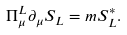<formula> <loc_0><loc_0><loc_500><loc_500>\Pi _ { \mu } ^ { L } \partial _ { \mu } S _ { L } = m S _ { L } ^ { * } .</formula> 